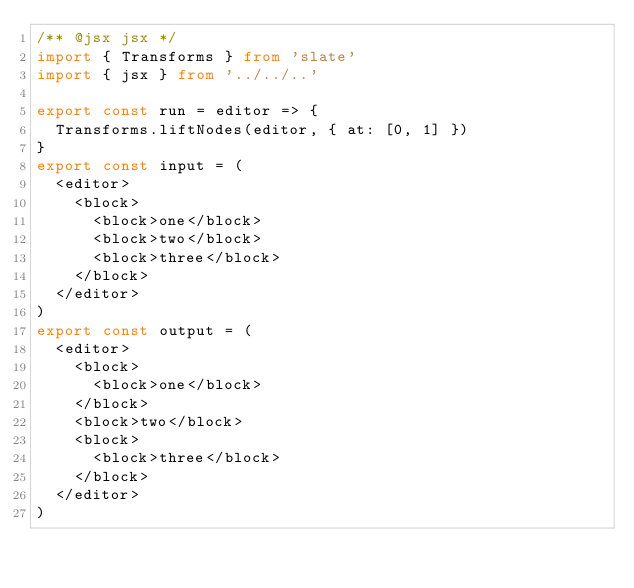<code> <loc_0><loc_0><loc_500><loc_500><_TypeScript_>/** @jsx jsx */
import { Transforms } from 'slate'
import { jsx } from '../../..'

export const run = editor => {
  Transforms.liftNodes(editor, { at: [0, 1] })
}
export const input = (
  <editor>
    <block>
      <block>one</block>
      <block>two</block>
      <block>three</block>
    </block>
  </editor>
)
export const output = (
  <editor>
    <block>
      <block>one</block>
    </block>
    <block>two</block>
    <block>
      <block>three</block>
    </block>
  </editor>
)
</code> 